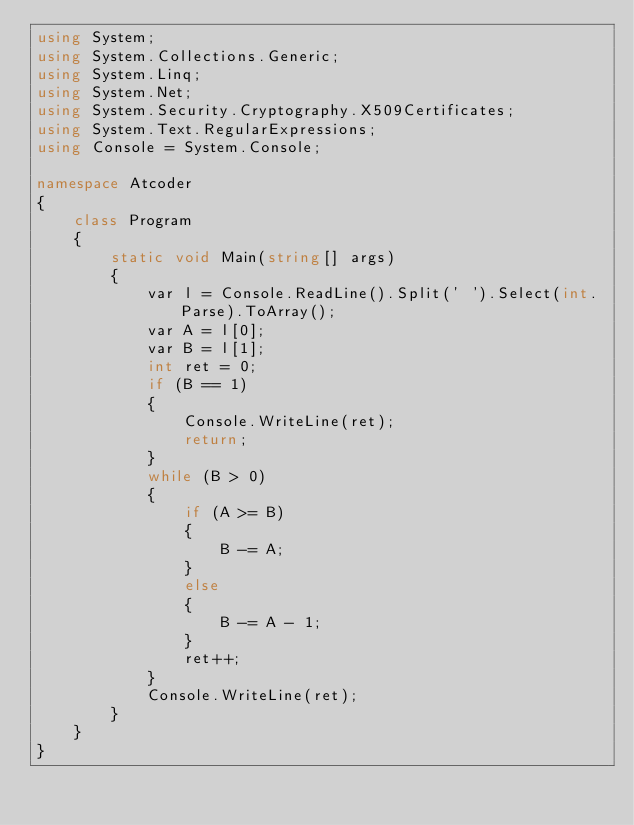Convert code to text. <code><loc_0><loc_0><loc_500><loc_500><_C#_>using System;
using System.Collections.Generic;
using System.Linq;
using System.Net;
using System.Security.Cryptography.X509Certificates;
using System.Text.RegularExpressions;
using Console = System.Console;

namespace Atcoder
{
    class Program
    {
        static void Main(string[] args)
        {
            var l = Console.ReadLine().Split(' ').Select(int.Parse).ToArray();
            var A = l[0];
            var B = l[1];
            int ret = 0;
            if (B == 1)
            {
                Console.WriteLine(ret);
                return;
            }
            while (B > 0)
            {
                if (A >= B)
                {
                    B -= A;
                }
                else
                {
                    B -= A - 1;
                }
                ret++;
            }
            Console.WriteLine(ret);
        }
    }
}</code> 